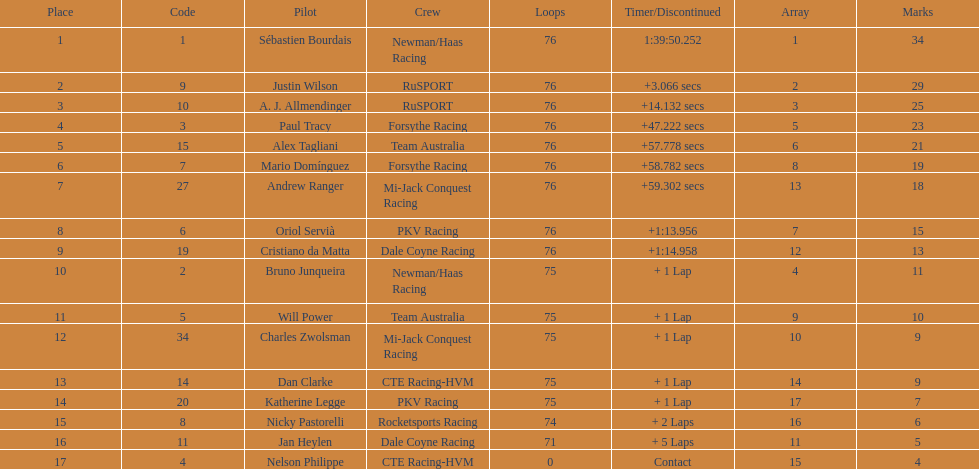Charles zwolsman acquired the same number of points as who? Dan Clarke. 